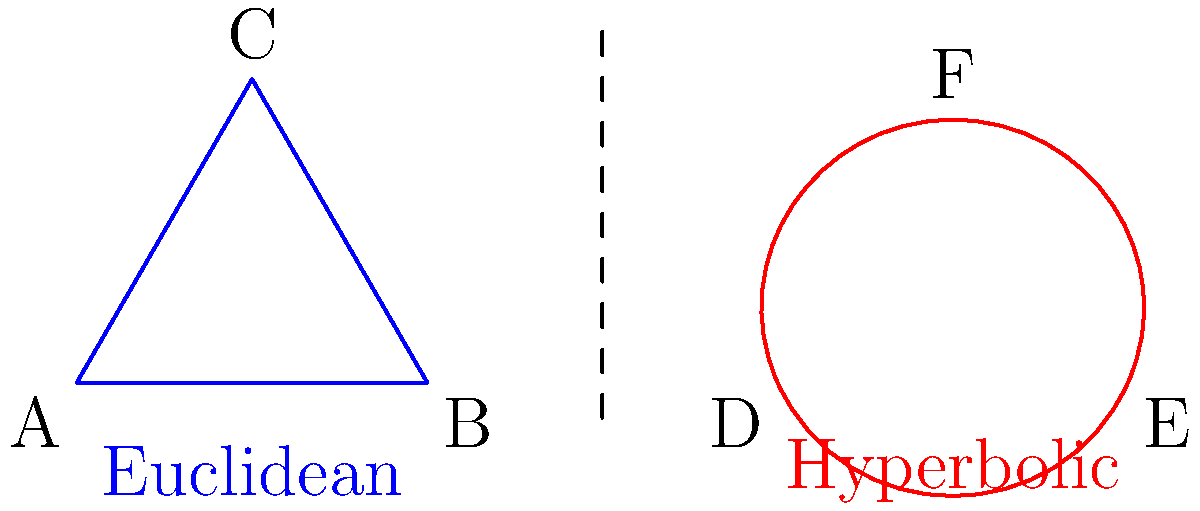In your military career, you've encountered various geometric principles. Consider the triangles shown above: one on a flat (Euclidean) plane and one on a hyperbolic plane. How does the sum of interior angles in the hyperbolic triangle (DEF) compare to the sum in the Euclidean triangle (ABC), which is known to be 180°?

a) Equal to 180°
b) Greater than 180°
c) Less than 180°
d) Cannot be determined Let's approach this step-by-step:

1. Euclidean Geometry:
   - In Euclidean (flat) geometry, the sum of interior angles of a triangle is always 180° or $\pi$ radians.
   - This is represented by triangle ABC in the diagram.

2. Hyperbolic Geometry:
   - Hyperbolic geometry is a non-Euclidean geometry where Euclid's parallel postulate doesn't hold.
   - In hyperbolic space, parallel lines "curve away" from each other.

3. Triangles in Hyperbolic Space:
   - Due to the curvature of hyperbolic space, the sum of interior angles of a triangle is always less than 180°.
   - This is represented by the curved triangle DEF in the diagram.

4. Comparison:
   - The sum of angles in a hyperbolic triangle decreases as the size of the triangle increases.
   - For any hyperbolic triangle, no matter how small, the sum will always be less than 180°.

5. Military Relevance:
   - Understanding non-Euclidean geometries can be crucial in advanced navigation systems and certain types of radar technology.

Therefore, the sum of interior angles in the hyperbolic triangle (DEF) is always less than the sum in the Euclidean triangle (ABC).
Answer: c) Less than 180° 